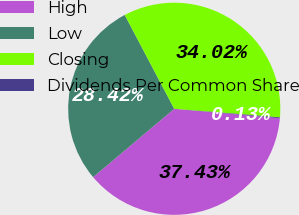<chart> <loc_0><loc_0><loc_500><loc_500><pie_chart><fcel>High<fcel>Low<fcel>Closing<fcel>Dividends Per Common Share<nl><fcel>37.43%<fcel>28.42%<fcel>34.02%<fcel>0.13%<nl></chart> 